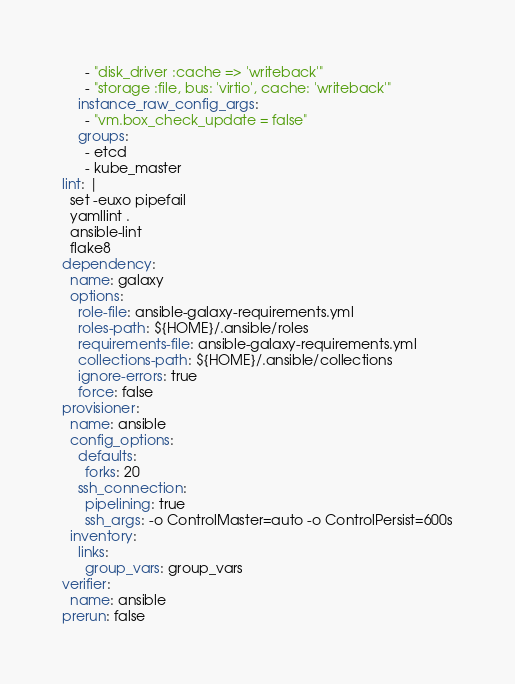Convert code to text. <code><loc_0><loc_0><loc_500><loc_500><_YAML_>      - "disk_driver :cache => 'writeback'"
      - "storage :file, bus: 'virtio', cache: 'writeback'"
    instance_raw_config_args:
      - "vm.box_check_update = false"
    groups:
      - etcd
      - kube_master
lint: |
  set -euxo pipefail
  yamllint .
  ansible-lint
  flake8
dependency:
  name: galaxy
  options:
    role-file: ansible-galaxy-requirements.yml
    roles-path: ${HOME}/.ansible/roles
    requirements-file: ansible-galaxy-requirements.yml
    collections-path: ${HOME}/.ansible/collections
    ignore-errors: true
    force: false
provisioner:
  name: ansible
  config_options:
    defaults:
      forks: 20
    ssh_connection:
      pipelining: true
      ssh_args: -o ControlMaster=auto -o ControlPersist=600s
  inventory:
    links:
      group_vars: group_vars
verifier:
  name: ansible
prerun: false
</code> 